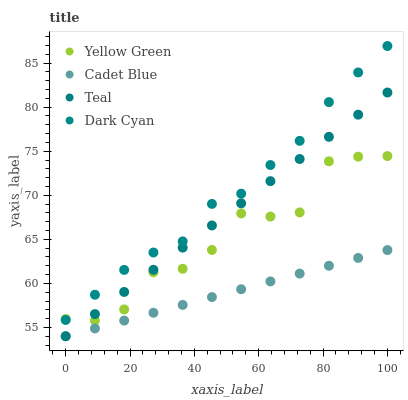Does Cadet Blue have the minimum area under the curve?
Answer yes or no. Yes. Does Dark Cyan have the maximum area under the curve?
Answer yes or no. Yes. Does Yellow Green have the minimum area under the curve?
Answer yes or no. No. Does Yellow Green have the maximum area under the curve?
Answer yes or no. No. Is Cadet Blue the smoothest?
Answer yes or no. Yes. Is Yellow Green the roughest?
Answer yes or no. Yes. Is Yellow Green the smoothest?
Answer yes or no. No. Is Cadet Blue the roughest?
Answer yes or no. No. Does Cadet Blue have the lowest value?
Answer yes or no. Yes. Does Yellow Green have the lowest value?
Answer yes or no. No. Does Dark Cyan have the highest value?
Answer yes or no. Yes. Does Yellow Green have the highest value?
Answer yes or no. No. Is Teal less than Dark Cyan?
Answer yes or no. Yes. Is Dark Cyan greater than Cadet Blue?
Answer yes or no. Yes. Does Teal intersect Cadet Blue?
Answer yes or no. Yes. Is Teal less than Cadet Blue?
Answer yes or no. No. Is Teal greater than Cadet Blue?
Answer yes or no. No. Does Teal intersect Dark Cyan?
Answer yes or no. No. 